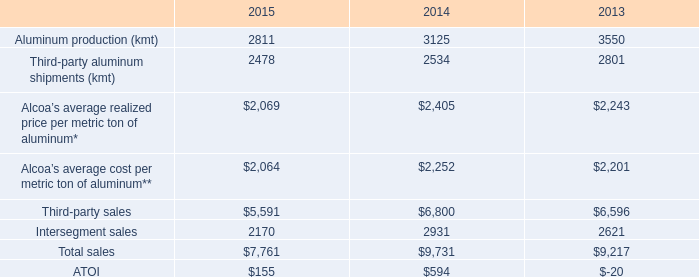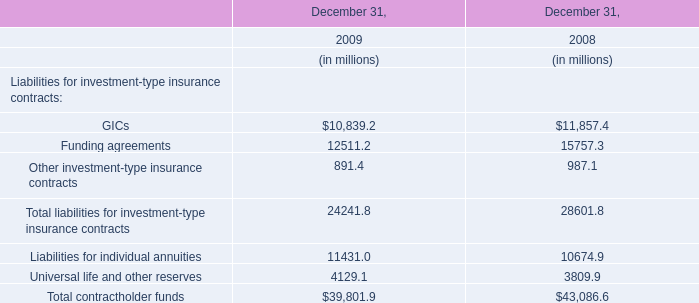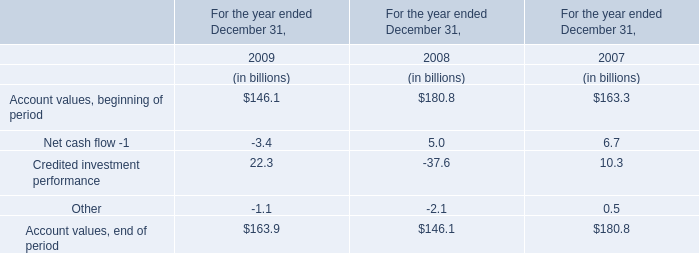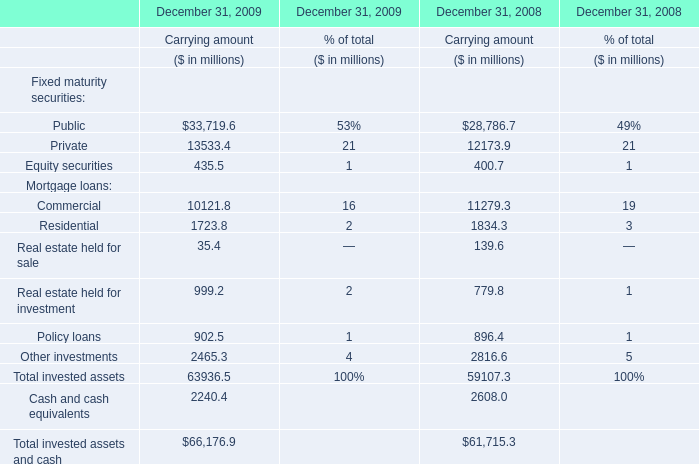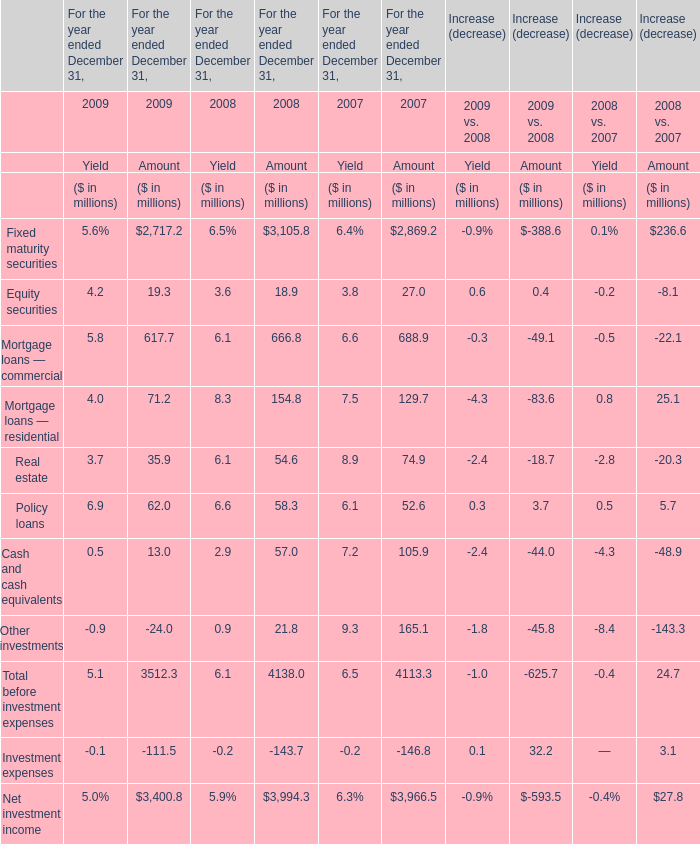what was the decrease in the number of dollars obtained with the sale of primary aluminum during 2013 and 2014? 
Computations: ((6800 * 90%) - (6596 * 90%))
Answer: 183.6. 